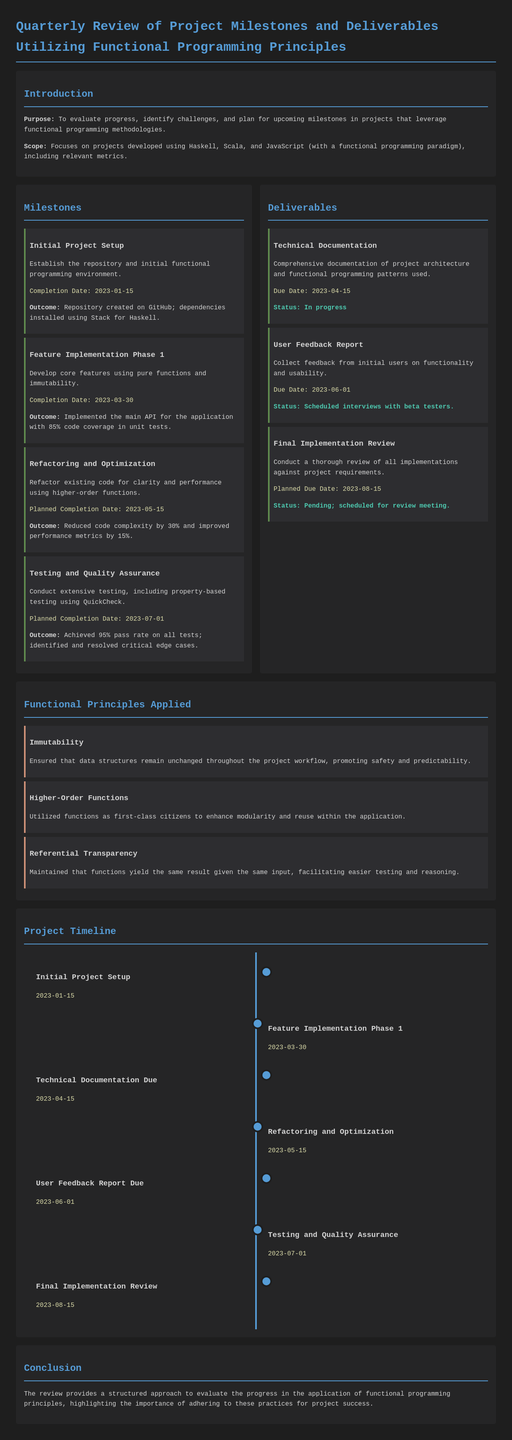What is the purpose of the quarterly review? The purpose is to evaluate progress, identify challenges, and plan for upcoming milestones in projects that leverage functional programming methodologies.
Answer: To evaluate progress, identify challenges, and plan for upcoming milestones What is the completion date for the Initial Project Setup milestone? The completion date for the Initial Project Setup milestone is specifically stated in the document.
Answer: 2023-01-15 How much code coverage was achieved in Feature Implementation Phase 1? This figure is mentioned as part of the outcomes for the Feature Implementation Phase in the milestones section.
Answer: 85% What is the status of the Technical Documentation deliverable? The status is indicated in the deliverables section, revealing the current state of progress on this item.
Answer: In progress When is the planned completion date for Testing and Quality Assurance? This date is mentioned as part of the details provided for this milestone.
Answer: 2023-07-01 Which functional programming principle ensures data structures remain unchanged? One of the principles outlined in the document specifically addresses this aspect.
Answer: Immutability What was the result of the Refactoring and Optimization milestone? The outcome provides a quantitative indication of performance improvement and complexity reduction.
Answer: Reduced code complexity by 30% and improved performance metrics by 15% What is the due date for the User Feedback Report? The due date for this deliverable is clearly mentioned in the document.
Answer: 2023-06-01 How many milestones are listed in total? The total number of milestones can be counted from the listed items in the milestones section.
Answer: Four 